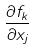<formula> <loc_0><loc_0><loc_500><loc_500>\frac { \partial f _ { k } } { \partial x _ { j } }</formula> 